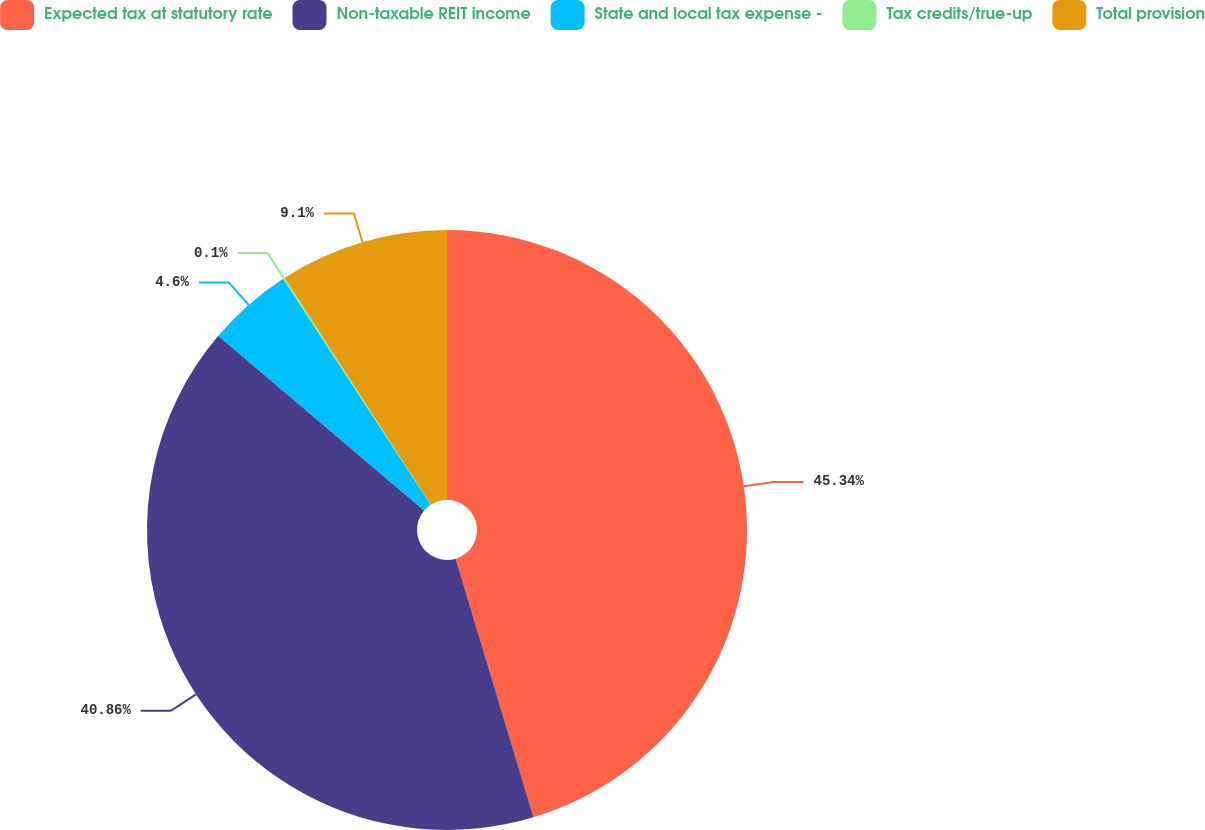Convert chart. <chart><loc_0><loc_0><loc_500><loc_500><pie_chart><fcel>Expected tax at statutory rate<fcel>Non-taxable REIT income<fcel>State and local tax expense -<fcel>Tax credits/true-up<fcel>Total provision<nl><fcel>45.35%<fcel>40.86%<fcel>4.6%<fcel>0.1%<fcel>9.1%<nl></chart> 